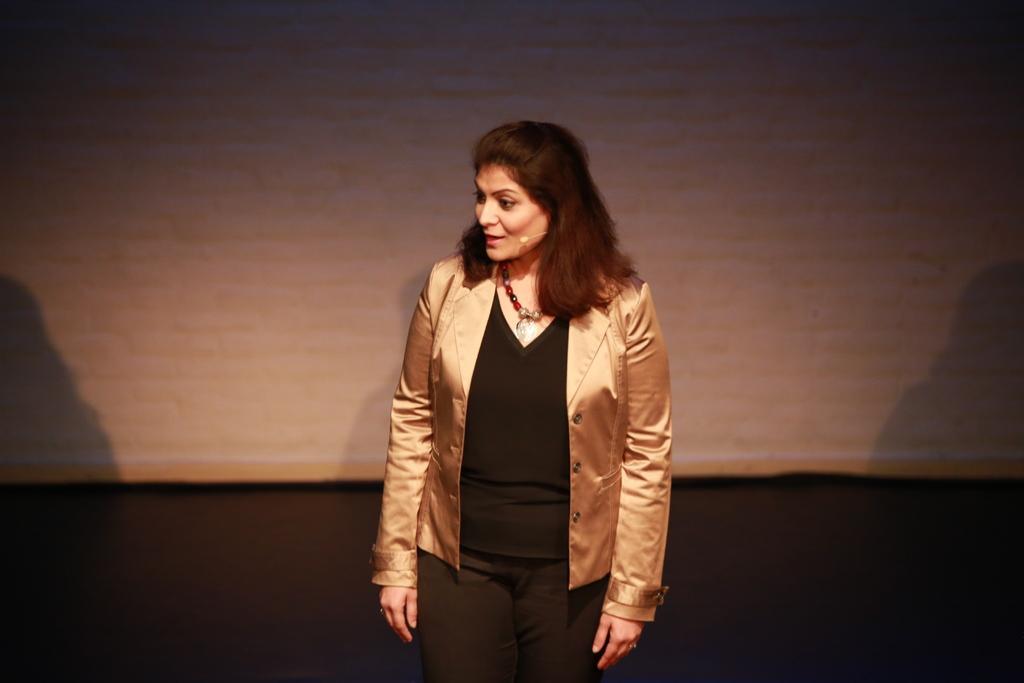Please provide a concise description of this image. In the middle a woman is there, she wore a gold color coat, black color dress. She is talking in the microphone. 